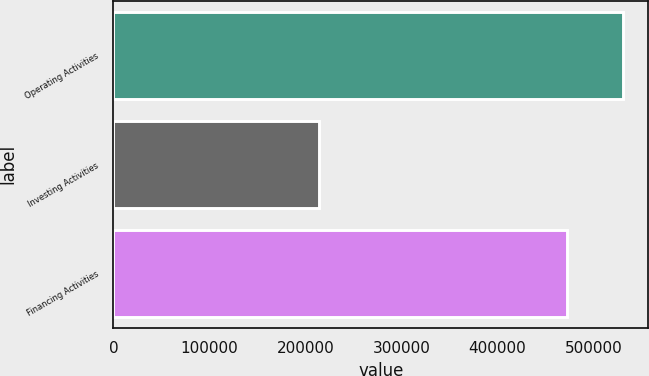Convert chart to OTSL. <chart><loc_0><loc_0><loc_500><loc_500><bar_chart><fcel>Operating Activities<fcel>Investing Activities<fcel>Financing Activities<nl><fcel>530309<fcel>214334<fcel>472573<nl></chart> 